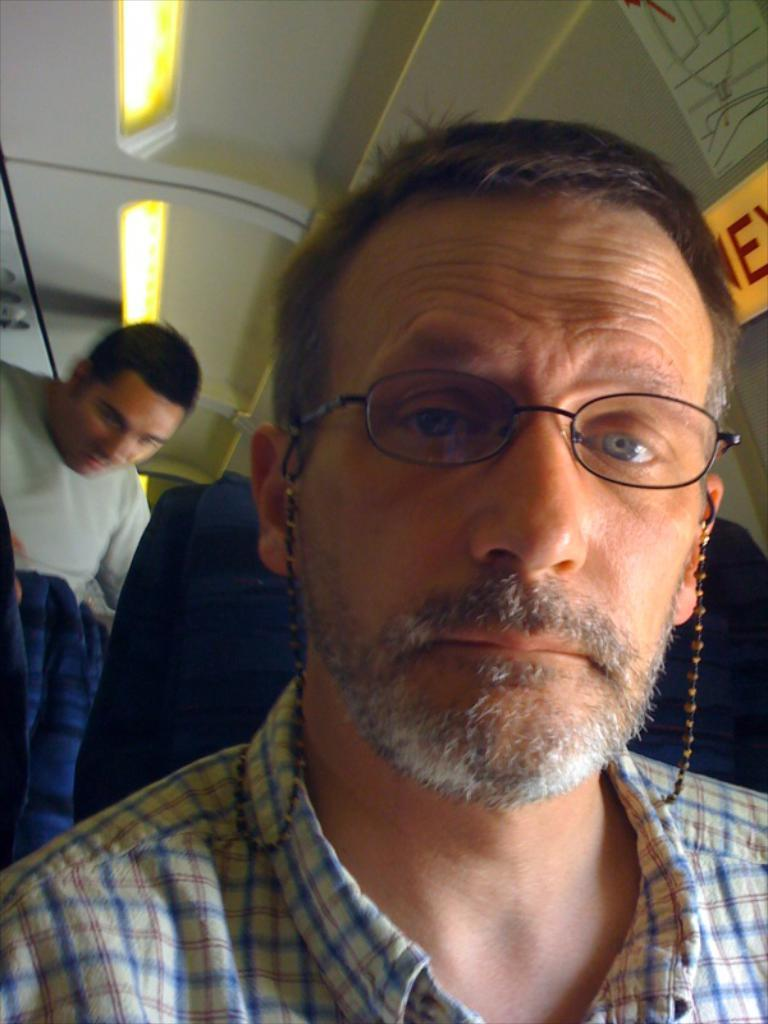What is the main subject in the foreground of the image? There is a person sitting in a chair in the foreground. Can you describe the other person in the image? There is another person on the left side of the image. What can be seen at the top of the image? The ceiling and a light are visible at the top of the image. What type of setting might the image depict? The image might have been taken inside a vehicle. What type of pest can be seen crawling on the person's jeans in the image? There is no pest visible on any person's jeans in the image. How many fingers does the person on the left side of the image have? The image does not provide enough detail to determine the number of fingers on the person's hand. 